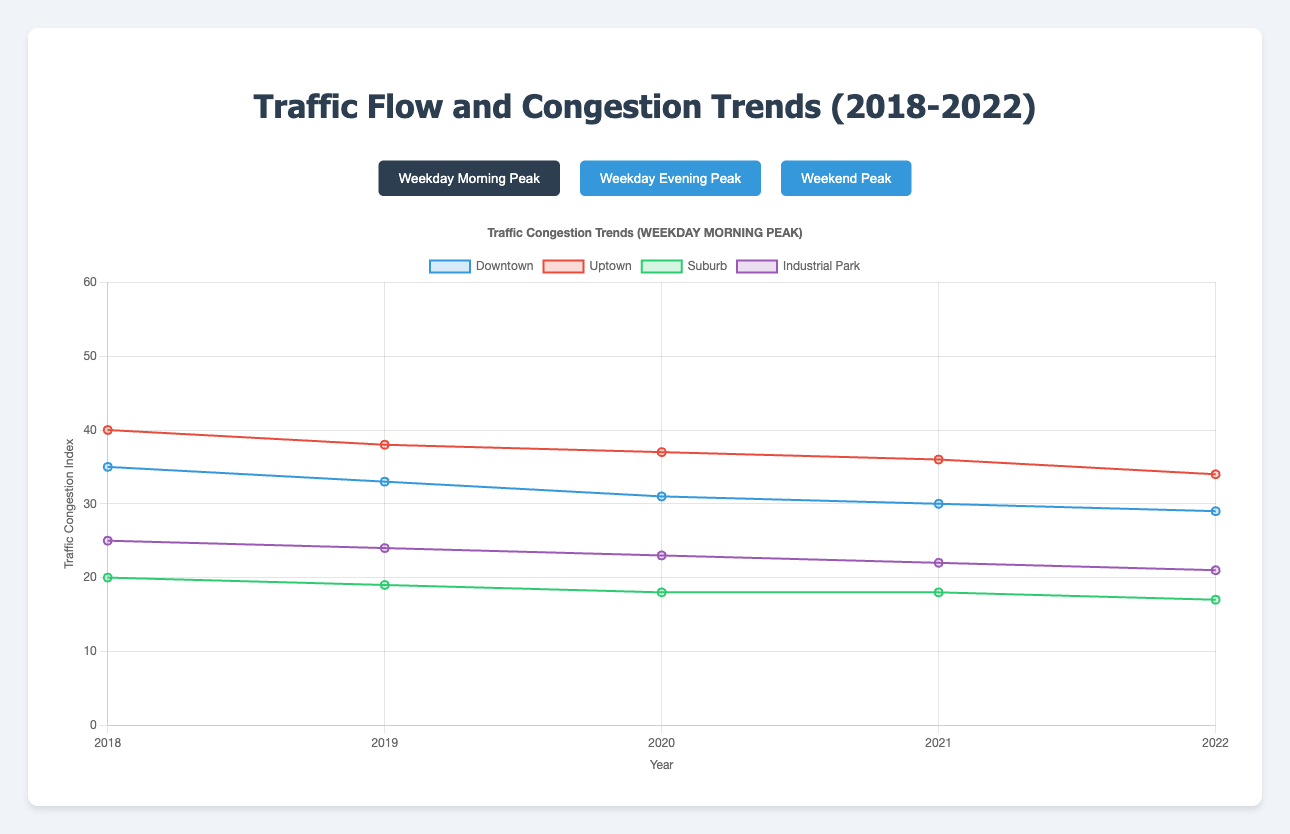What's the trend of traffic congestion in Downtown during the weekday morning peak from 2018 to 2022? From 2018 to 2022, the traffic congestion in Downtown during weekday morning peak has shown a decreasing trend. It starts at 35 in 2018 and gradually decreases to 29 in 2022.
Answer: Decreasing During the weekday evening peak, which area had the highest congestion in 2019? In the weekday evening peak of 2019, Uptown had the highest congestion with a value of 48. This is observed by comparing the values of all areas (Downtown: 44, Uptown: 48, Suburb: 27, Industrial Park: 29).
Answer: Uptown Comparing the weekday morning peak and evening peak in Downtown, which year had the biggest difference in congestion levels? The biggest difference in Downtown congestion levels between the weekday morning peak and weekday evening peak occurs in 2018. The difference is (45 - 35) = 10, which is the largest compared to subsequent years with differences of 11, 11, 10, and 9 respectively.
Answer: 2018 What's the average congestion level in Suburb during the weekend peak from 2018 to 2022? The weekend peak congestion levels in Suburb from 2018 to 2022 are [15, 15, 14, 14, 13]. Summing them gives 71, and dividing by 5 gives the average: 71/5 = 14.2.
Answer: 14.2 Which area has the most significant reduction in congestion from 2018 to 2022 during the weekday morning peak? The most significant reduction in congestion from 2018 to 2022 during weekday morning peak is Uptown. Uptown's values change from 40 to 34, a reduction of 6, which is the largest among all areas (Downtown: 6, Uptown: 6, Suburb: 3, Industrial Park: 4).
Answer: Uptown During the weekend peak, which area had the least congestion level in 2020? In the weekend peak of 2020, Suburb had the least congestion level with a value of 14. This can be seen by comparing all areas' values: Downtown (24), Uptown (28), Suburb (14), and Industrial Park (17).
Answer: Suburb How does the congestion level in Industrial Park compare in the weekday evening peak of 2021 versus 2022? In the weekday evening peak, Industrial Park congestion level decreases from 26 in 2021 to 25 in 2022. To find this, look into the data for values corresponding to 2021 and 2022.
Answer: Decreases Which year recorded the lowest congestion levels for Uptown during the weekday morning peak? The year 2022 recorded the lowest congestion levels for Uptown during the weekday morning peak, with a value of 34. This can be identified by comparing each year's values.
Answer: 2022 In 2019, what is the difference in traffic congestion between Uptown and Suburb during the weekend peak? In the weekend peak of 2019, Uptown had a congestion level of 28, while Suburb's level was 15. The difference is 28 - 15 = 13.
Answer: 13 